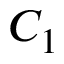Convert formula to latex. <formula><loc_0><loc_0><loc_500><loc_500>C _ { 1 }</formula> 